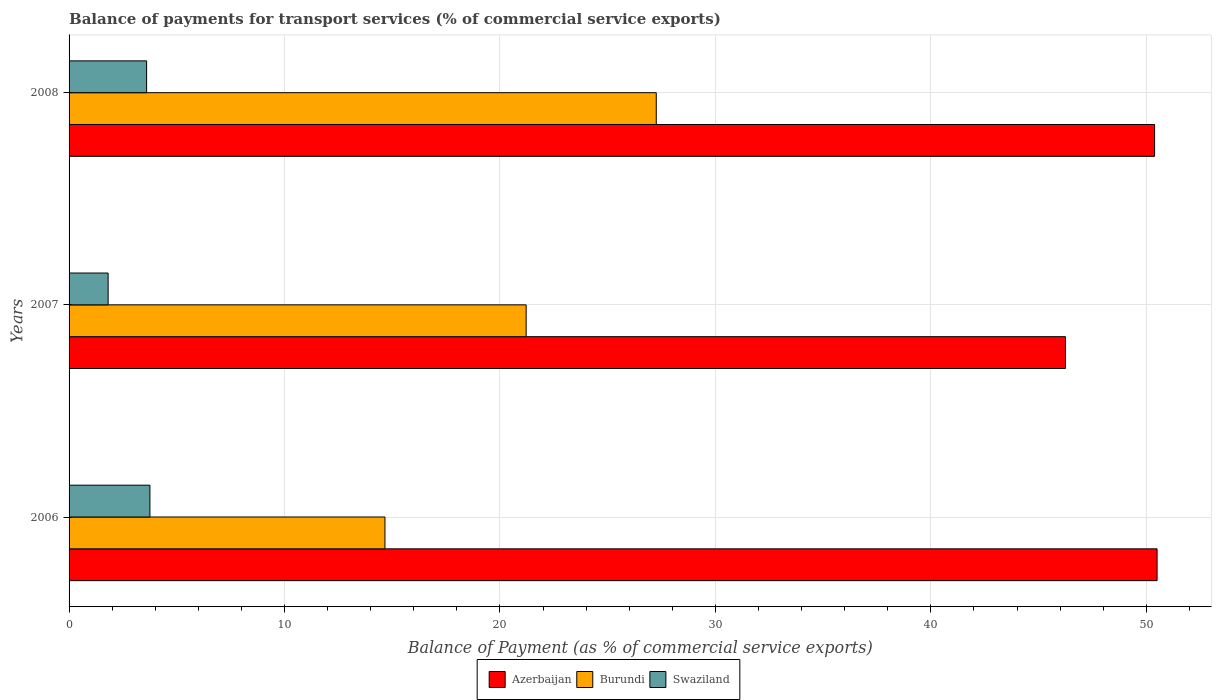How many different coloured bars are there?
Provide a succinct answer. 3. How many groups of bars are there?
Provide a succinct answer. 3. Are the number of bars on each tick of the Y-axis equal?
Ensure brevity in your answer.  Yes. How many bars are there on the 1st tick from the top?
Provide a short and direct response. 3. How many bars are there on the 1st tick from the bottom?
Ensure brevity in your answer.  3. What is the label of the 1st group of bars from the top?
Give a very brief answer. 2008. In how many cases, is the number of bars for a given year not equal to the number of legend labels?
Provide a succinct answer. 0. What is the balance of payments for transport services in Swaziland in 2007?
Your response must be concise. 1.81. Across all years, what is the maximum balance of payments for transport services in Swaziland?
Your answer should be very brief. 3.75. Across all years, what is the minimum balance of payments for transport services in Burundi?
Give a very brief answer. 14.66. In which year was the balance of payments for transport services in Burundi maximum?
Offer a terse response. 2008. In which year was the balance of payments for transport services in Swaziland minimum?
Ensure brevity in your answer.  2007. What is the total balance of payments for transport services in Swaziland in the graph?
Make the answer very short. 9.16. What is the difference between the balance of payments for transport services in Swaziland in 2006 and that in 2007?
Provide a short and direct response. 1.94. What is the difference between the balance of payments for transport services in Azerbaijan in 2006 and the balance of payments for transport services in Burundi in 2007?
Provide a succinct answer. 29.29. What is the average balance of payments for transport services in Burundi per year?
Provide a short and direct response. 21.04. In the year 2007, what is the difference between the balance of payments for transport services in Burundi and balance of payments for transport services in Azerbaijan?
Provide a succinct answer. -25.03. What is the ratio of the balance of payments for transport services in Burundi in 2006 to that in 2008?
Provide a succinct answer. 0.54. Is the balance of payments for transport services in Swaziland in 2006 less than that in 2007?
Your response must be concise. No. What is the difference between the highest and the second highest balance of payments for transport services in Azerbaijan?
Ensure brevity in your answer.  0.12. What is the difference between the highest and the lowest balance of payments for transport services in Burundi?
Offer a very short reply. 12.59. In how many years, is the balance of payments for transport services in Burundi greater than the average balance of payments for transport services in Burundi taken over all years?
Offer a very short reply. 2. Is the sum of the balance of payments for transport services in Burundi in 2006 and 2008 greater than the maximum balance of payments for transport services in Azerbaijan across all years?
Offer a very short reply. No. What does the 1st bar from the top in 2008 represents?
Give a very brief answer. Swaziland. What does the 3rd bar from the bottom in 2006 represents?
Offer a very short reply. Swaziland. Are all the bars in the graph horizontal?
Your answer should be very brief. Yes. How many years are there in the graph?
Provide a short and direct response. 3. What is the difference between two consecutive major ticks on the X-axis?
Your answer should be compact. 10. Are the values on the major ticks of X-axis written in scientific E-notation?
Keep it short and to the point. No. Does the graph contain any zero values?
Offer a terse response. No. Does the graph contain grids?
Keep it short and to the point. Yes. Where does the legend appear in the graph?
Offer a terse response. Bottom center. What is the title of the graph?
Provide a succinct answer. Balance of payments for transport services (% of commercial service exports). Does "St. Martin (French part)" appear as one of the legend labels in the graph?
Keep it short and to the point. No. What is the label or title of the X-axis?
Offer a very short reply. Balance of Payment (as % of commercial service exports). What is the label or title of the Y-axis?
Make the answer very short. Years. What is the Balance of Payment (as % of commercial service exports) in Azerbaijan in 2006?
Provide a short and direct response. 50.5. What is the Balance of Payment (as % of commercial service exports) in Burundi in 2006?
Provide a succinct answer. 14.66. What is the Balance of Payment (as % of commercial service exports) of Swaziland in 2006?
Offer a terse response. 3.75. What is the Balance of Payment (as % of commercial service exports) of Azerbaijan in 2007?
Provide a succinct answer. 46.25. What is the Balance of Payment (as % of commercial service exports) of Burundi in 2007?
Keep it short and to the point. 21.22. What is the Balance of Payment (as % of commercial service exports) of Swaziland in 2007?
Your answer should be compact. 1.81. What is the Balance of Payment (as % of commercial service exports) in Azerbaijan in 2008?
Provide a short and direct response. 50.39. What is the Balance of Payment (as % of commercial service exports) of Burundi in 2008?
Your answer should be compact. 27.26. What is the Balance of Payment (as % of commercial service exports) of Swaziland in 2008?
Give a very brief answer. 3.6. Across all years, what is the maximum Balance of Payment (as % of commercial service exports) of Azerbaijan?
Your answer should be very brief. 50.5. Across all years, what is the maximum Balance of Payment (as % of commercial service exports) of Burundi?
Offer a terse response. 27.26. Across all years, what is the maximum Balance of Payment (as % of commercial service exports) of Swaziland?
Offer a very short reply. 3.75. Across all years, what is the minimum Balance of Payment (as % of commercial service exports) of Azerbaijan?
Make the answer very short. 46.25. Across all years, what is the minimum Balance of Payment (as % of commercial service exports) of Burundi?
Ensure brevity in your answer.  14.66. Across all years, what is the minimum Balance of Payment (as % of commercial service exports) in Swaziland?
Provide a short and direct response. 1.81. What is the total Balance of Payment (as % of commercial service exports) of Azerbaijan in the graph?
Keep it short and to the point. 147.14. What is the total Balance of Payment (as % of commercial service exports) in Burundi in the graph?
Your response must be concise. 63.13. What is the total Balance of Payment (as % of commercial service exports) of Swaziland in the graph?
Provide a short and direct response. 9.16. What is the difference between the Balance of Payment (as % of commercial service exports) in Azerbaijan in 2006 and that in 2007?
Ensure brevity in your answer.  4.25. What is the difference between the Balance of Payment (as % of commercial service exports) in Burundi in 2006 and that in 2007?
Offer a terse response. -6.55. What is the difference between the Balance of Payment (as % of commercial service exports) in Swaziland in 2006 and that in 2007?
Offer a terse response. 1.94. What is the difference between the Balance of Payment (as % of commercial service exports) in Azerbaijan in 2006 and that in 2008?
Provide a succinct answer. 0.12. What is the difference between the Balance of Payment (as % of commercial service exports) of Burundi in 2006 and that in 2008?
Provide a succinct answer. -12.59. What is the difference between the Balance of Payment (as % of commercial service exports) in Swaziland in 2006 and that in 2008?
Your answer should be very brief. 0.15. What is the difference between the Balance of Payment (as % of commercial service exports) of Azerbaijan in 2007 and that in 2008?
Give a very brief answer. -4.14. What is the difference between the Balance of Payment (as % of commercial service exports) in Burundi in 2007 and that in 2008?
Keep it short and to the point. -6.04. What is the difference between the Balance of Payment (as % of commercial service exports) in Swaziland in 2007 and that in 2008?
Ensure brevity in your answer.  -1.79. What is the difference between the Balance of Payment (as % of commercial service exports) of Azerbaijan in 2006 and the Balance of Payment (as % of commercial service exports) of Burundi in 2007?
Make the answer very short. 29.29. What is the difference between the Balance of Payment (as % of commercial service exports) of Azerbaijan in 2006 and the Balance of Payment (as % of commercial service exports) of Swaziland in 2007?
Keep it short and to the point. 48.69. What is the difference between the Balance of Payment (as % of commercial service exports) in Burundi in 2006 and the Balance of Payment (as % of commercial service exports) in Swaziland in 2007?
Provide a succinct answer. 12.85. What is the difference between the Balance of Payment (as % of commercial service exports) in Azerbaijan in 2006 and the Balance of Payment (as % of commercial service exports) in Burundi in 2008?
Your answer should be compact. 23.25. What is the difference between the Balance of Payment (as % of commercial service exports) in Azerbaijan in 2006 and the Balance of Payment (as % of commercial service exports) in Swaziland in 2008?
Give a very brief answer. 46.9. What is the difference between the Balance of Payment (as % of commercial service exports) of Burundi in 2006 and the Balance of Payment (as % of commercial service exports) of Swaziland in 2008?
Make the answer very short. 11.06. What is the difference between the Balance of Payment (as % of commercial service exports) of Azerbaijan in 2007 and the Balance of Payment (as % of commercial service exports) of Burundi in 2008?
Your answer should be very brief. 18.99. What is the difference between the Balance of Payment (as % of commercial service exports) of Azerbaijan in 2007 and the Balance of Payment (as % of commercial service exports) of Swaziland in 2008?
Make the answer very short. 42.65. What is the difference between the Balance of Payment (as % of commercial service exports) of Burundi in 2007 and the Balance of Payment (as % of commercial service exports) of Swaziland in 2008?
Provide a short and direct response. 17.62. What is the average Balance of Payment (as % of commercial service exports) in Azerbaijan per year?
Ensure brevity in your answer.  49.05. What is the average Balance of Payment (as % of commercial service exports) of Burundi per year?
Provide a succinct answer. 21.04. What is the average Balance of Payment (as % of commercial service exports) of Swaziland per year?
Ensure brevity in your answer.  3.05. In the year 2006, what is the difference between the Balance of Payment (as % of commercial service exports) in Azerbaijan and Balance of Payment (as % of commercial service exports) in Burundi?
Provide a succinct answer. 35.84. In the year 2006, what is the difference between the Balance of Payment (as % of commercial service exports) in Azerbaijan and Balance of Payment (as % of commercial service exports) in Swaziland?
Keep it short and to the point. 46.75. In the year 2006, what is the difference between the Balance of Payment (as % of commercial service exports) of Burundi and Balance of Payment (as % of commercial service exports) of Swaziland?
Provide a succinct answer. 10.91. In the year 2007, what is the difference between the Balance of Payment (as % of commercial service exports) of Azerbaijan and Balance of Payment (as % of commercial service exports) of Burundi?
Your answer should be compact. 25.03. In the year 2007, what is the difference between the Balance of Payment (as % of commercial service exports) of Azerbaijan and Balance of Payment (as % of commercial service exports) of Swaziland?
Provide a short and direct response. 44.44. In the year 2007, what is the difference between the Balance of Payment (as % of commercial service exports) of Burundi and Balance of Payment (as % of commercial service exports) of Swaziland?
Make the answer very short. 19.4. In the year 2008, what is the difference between the Balance of Payment (as % of commercial service exports) of Azerbaijan and Balance of Payment (as % of commercial service exports) of Burundi?
Provide a short and direct response. 23.13. In the year 2008, what is the difference between the Balance of Payment (as % of commercial service exports) in Azerbaijan and Balance of Payment (as % of commercial service exports) in Swaziland?
Give a very brief answer. 46.79. In the year 2008, what is the difference between the Balance of Payment (as % of commercial service exports) of Burundi and Balance of Payment (as % of commercial service exports) of Swaziland?
Your response must be concise. 23.66. What is the ratio of the Balance of Payment (as % of commercial service exports) of Azerbaijan in 2006 to that in 2007?
Provide a succinct answer. 1.09. What is the ratio of the Balance of Payment (as % of commercial service exports) of Burundi in 2006 to that in 2007?
Offer a very short reply. 0.69. What is the ratio of the Balance of Payment (as % of commercial service exports) in Swaziland in 2006 to that in 2007?
Make the answer very short. 2.07. What is the ratio of the Balance of Payment (as % of commercial service exports) in Azerbaijan in 2006 to that in 2008?
Ensure brevity in your answer.  1. What is the ratio of the Balance of Payment (as % of commercial service exports) of Burundi in 2006 to that in 2008?
Ensure brevity in your answer.  0.54. What is the ratio of the Balance of Payment (as % of commercial service exports) in Swaziland in 2006 to that in 2008?
Ensure brevity in your answer.  1.04. What is the ratio of the Balance of Payment (as % of commercial service exports) of Azerbaijan in 2007 to that in 2008?
Ensure brevity in your answer.  0.92. What is the ratio of the Balance of Payment (as % of commercial service exports) in Burundi in 2007 to that in 2008?
Your answer should be compact. 0.78. What is the ratio of the Balance of Payment (as % of commercial service exports) in Swaziland in 2007 to that in 2008?
Provide a succinct answer. 0.5. What is the difference between the highest and the second highest Balance of Payment (as % of commercial service exports) in Azerbaijan?
Your answer should be compact. 0.12. What is the difference between the highest and the second highest Balance of Payment (as % of commercial service exports) in Burundi?
Make the answer very short. 6.04. What is the difference between the highest and the second highest Balance of Payment (as % of commercial service exports) in Swaziland?
Provide a succinct answer. 0.15. What is the difference between the highest and the lowest Balance of Payment (as % of commercial service exports) in Azerbaijan?
Offer a very short reply. 4.25. What is the difference between the highest and the lowest Balance of Payment (as % of commercial service exports) in Burundi?
Provide a short and direct response. 12.59. What is the difference between the highest and the lowest Balance of Payment (as % of commercial service exports) of Swaziland?
Ensure brevity in your answer.  1.94. 